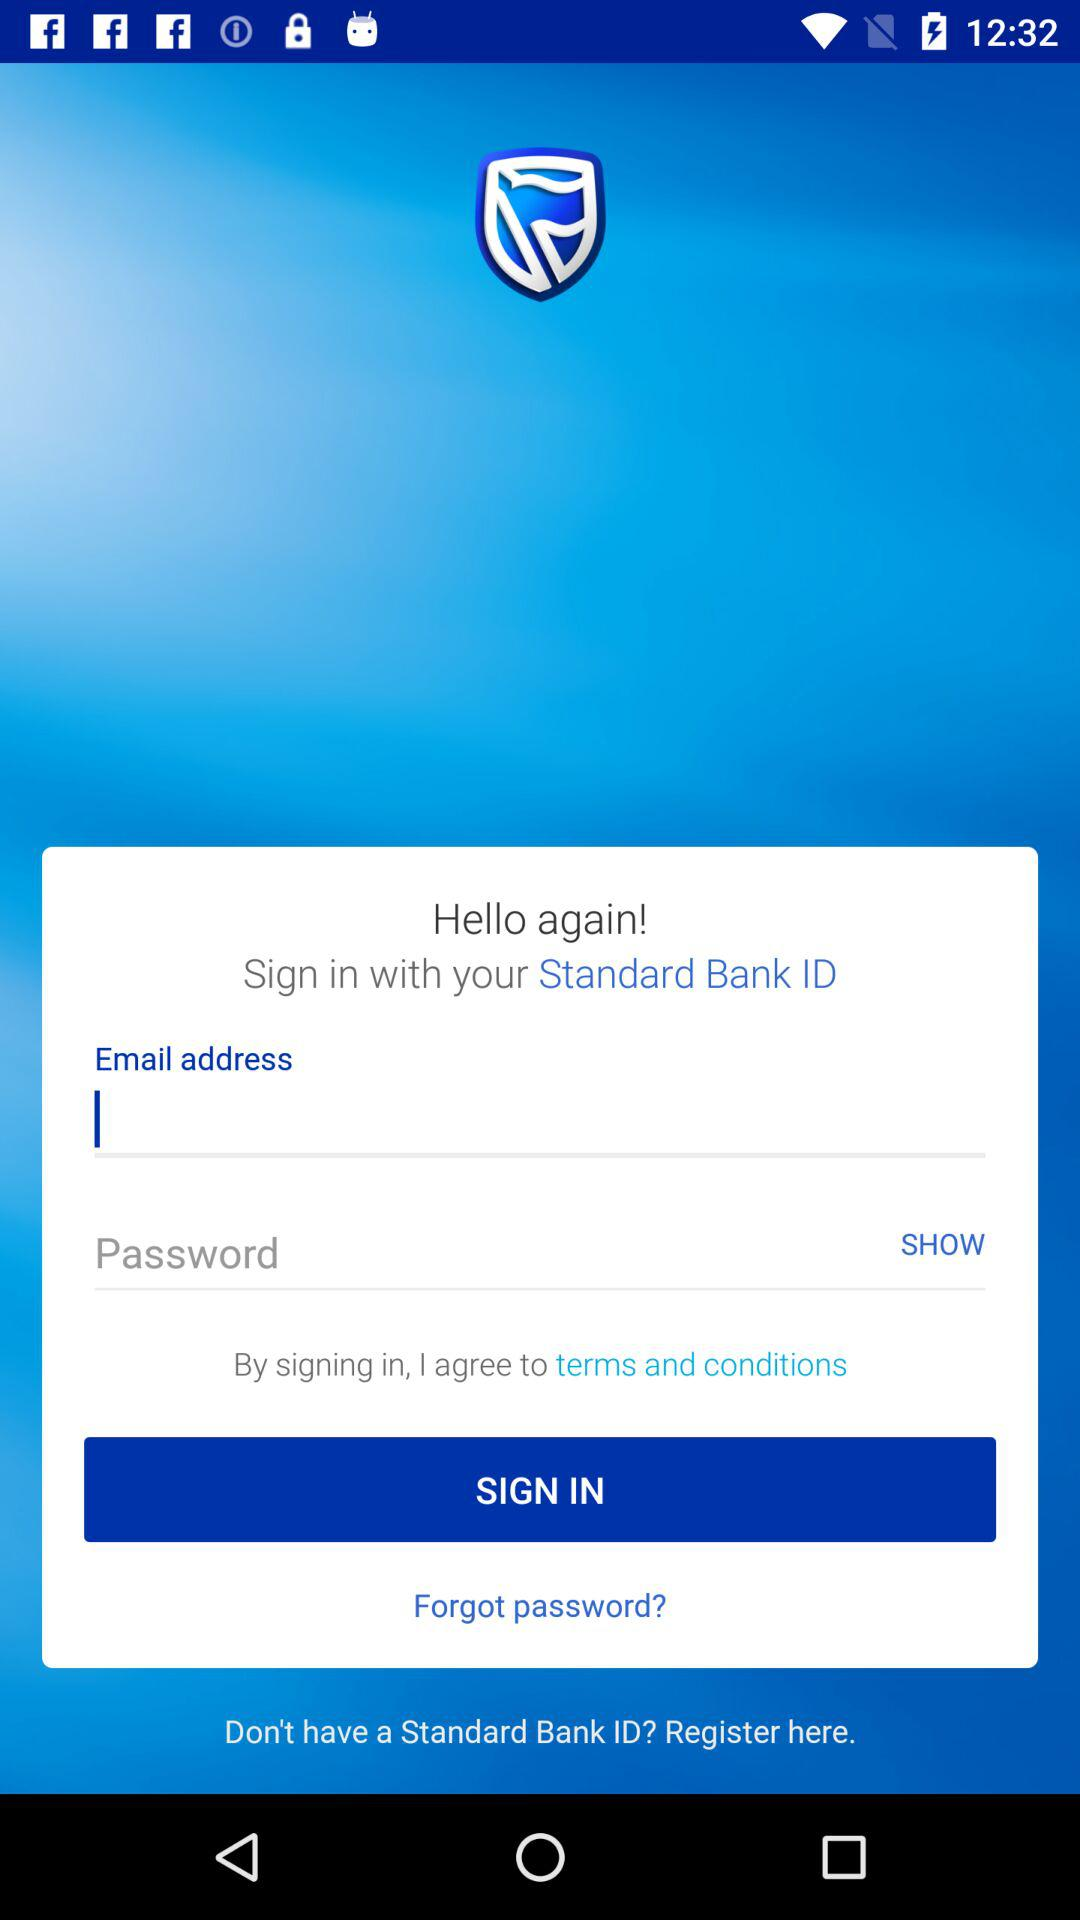How many characters are required for the password?
When the provided information is insufficient, respond with <no answer>. <no answer> 